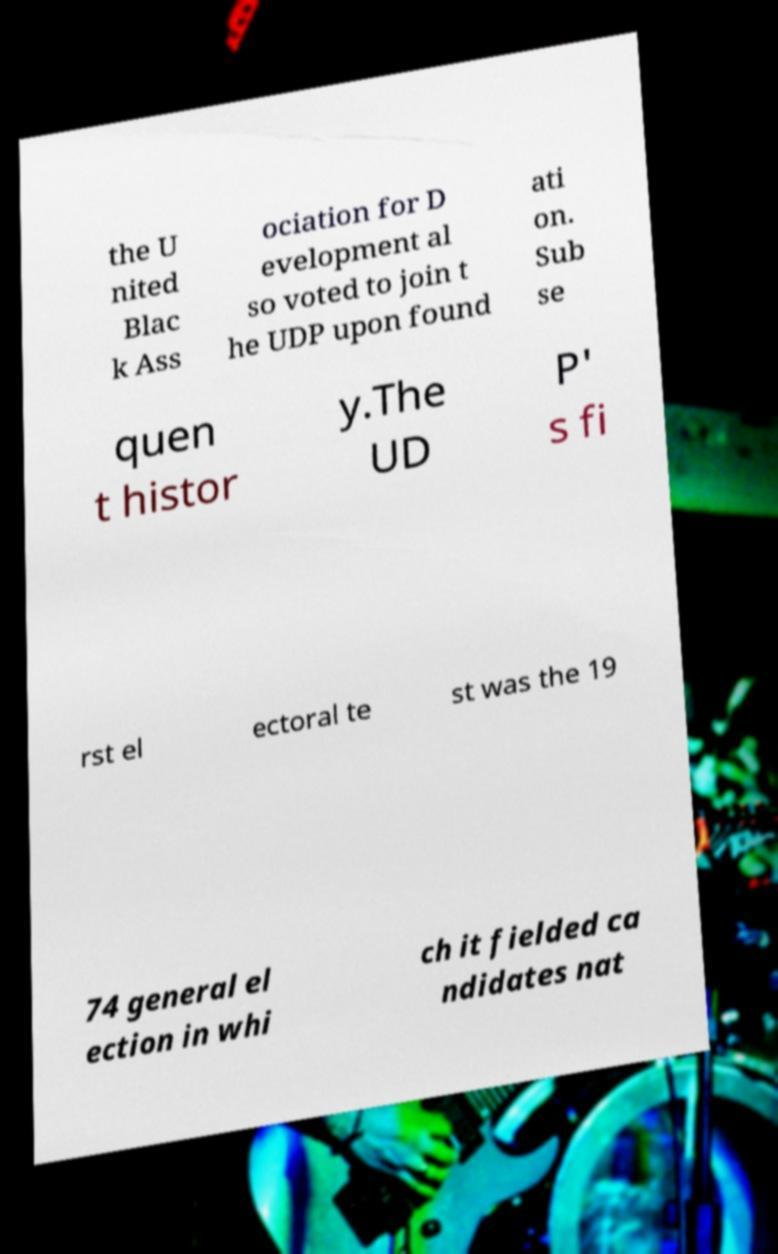Please read and relay the text visible in this image. What does it say? the U nited Blac k Ass ociation for D evelopment al so voted to join t he UDP upon found ati on. Sub se quen t histor y.The UD P' s fi rst el ectoral te st was the 19 74 general el ection in whi ch it fielded ca ndidates nat 